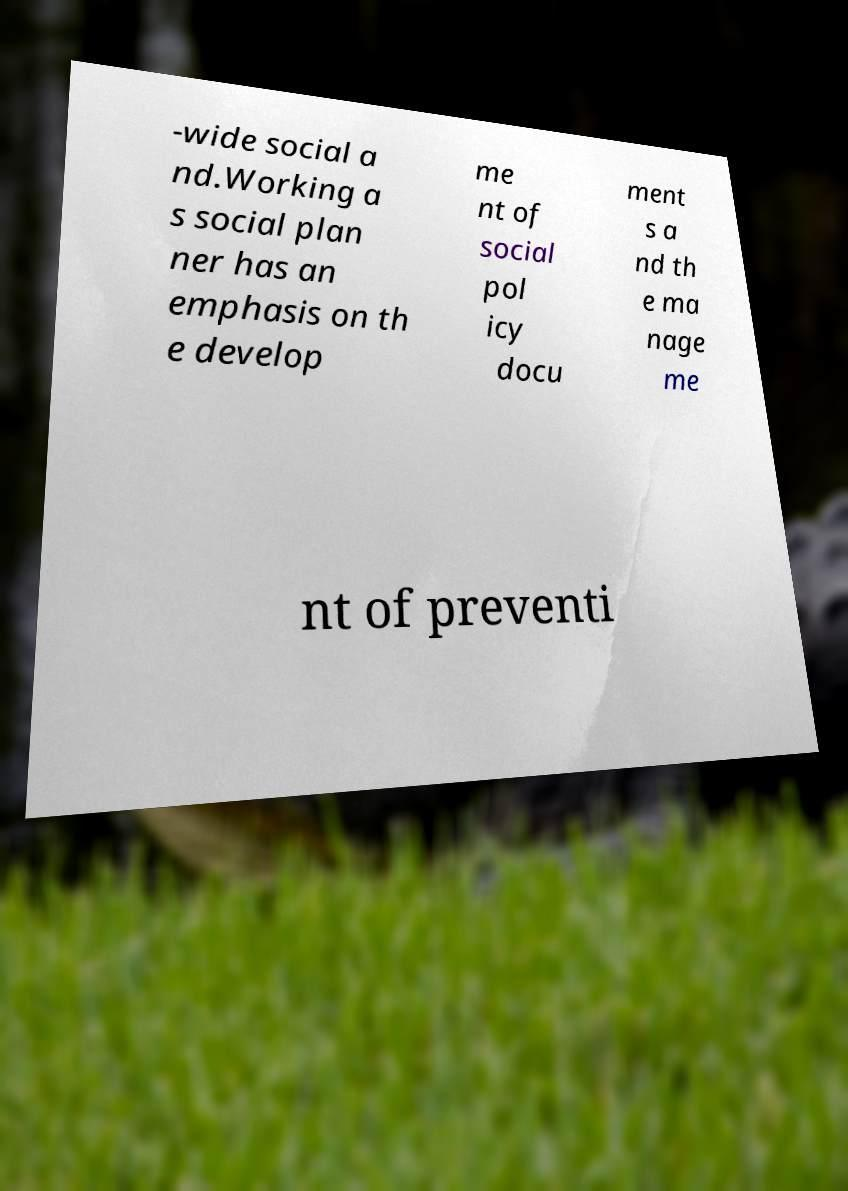I need the written content from this picture converted into text. Can you do that? -wide social a nd.Working a s social plan ner has an emphasis on th e develop me nt of social pol icy docu ment s a nd th e ma nage me nt of preventi 